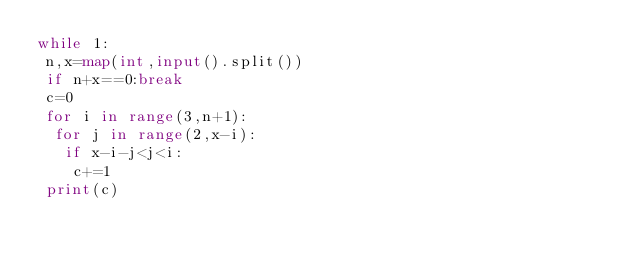Convert code to text. <code><loc_0><loc_0><loc_500><loc_500><_Python_>while 1:
 n,x=map(int,input().split())
 if n+x==0:break
 c=0
 for i in range(3,n+1):
  for j in range(2,x-i):
   if x-i-j<j<i:
    c+=1
 print(c)</code> 